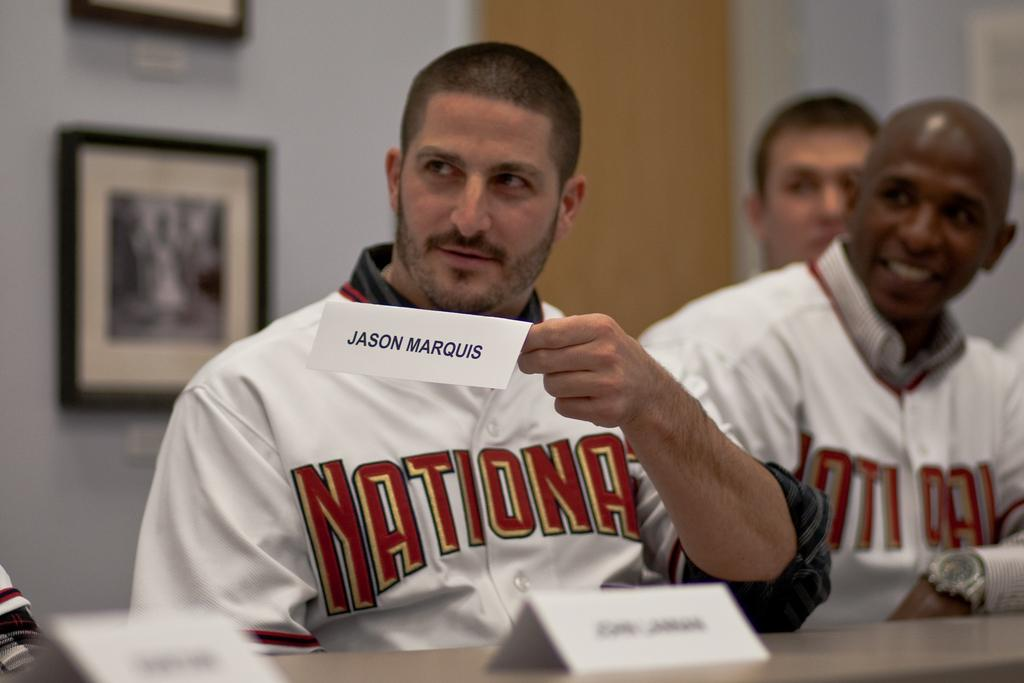<image>
Render a clear and concise summary of the photo. Man holding a rectangular white card with Jason Marquis in black lettering. 